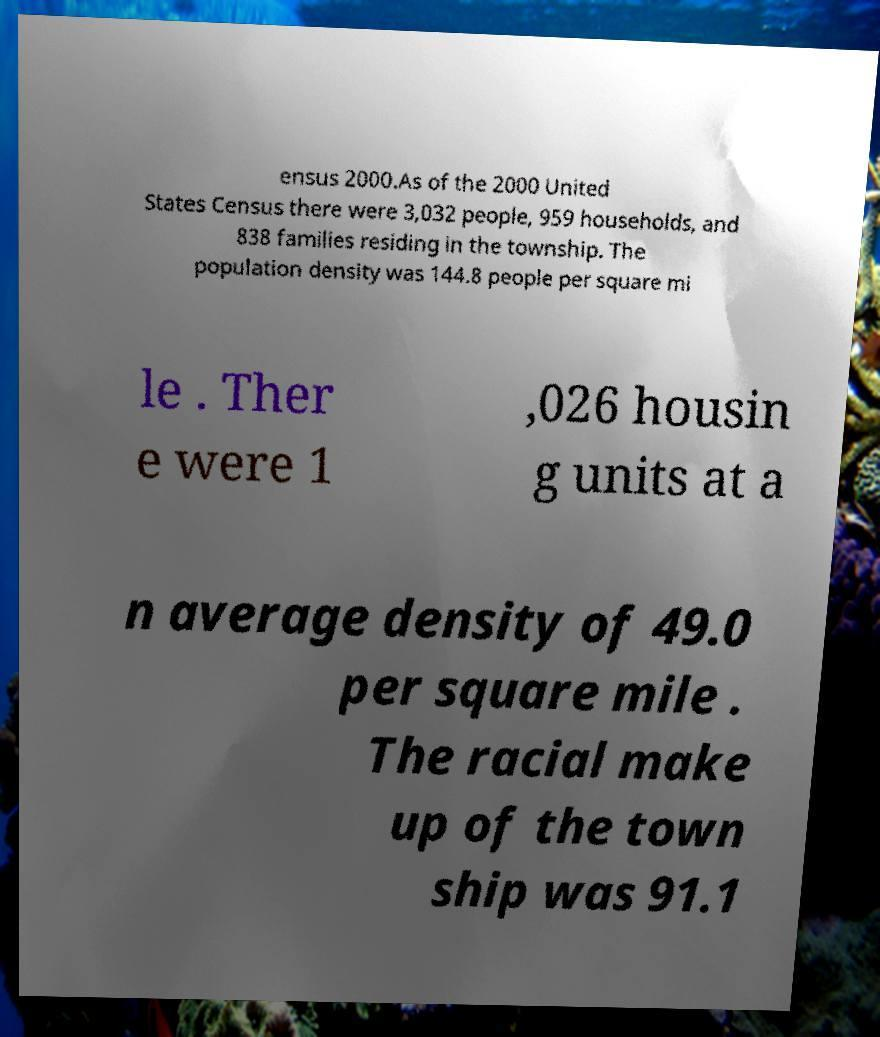What messages or text are displayed in this image? I need them in a readable, typed format. ensus 2000.As of the 2000 United States Census there were 3,032 people, 959 households, and 838 families residing in the township. The population density was 144.8 people per square mi le . Ther e were 1 ,026 housin g units at a n average density of 49.0 per square mile . The racial make up of the town ship was 91.1 